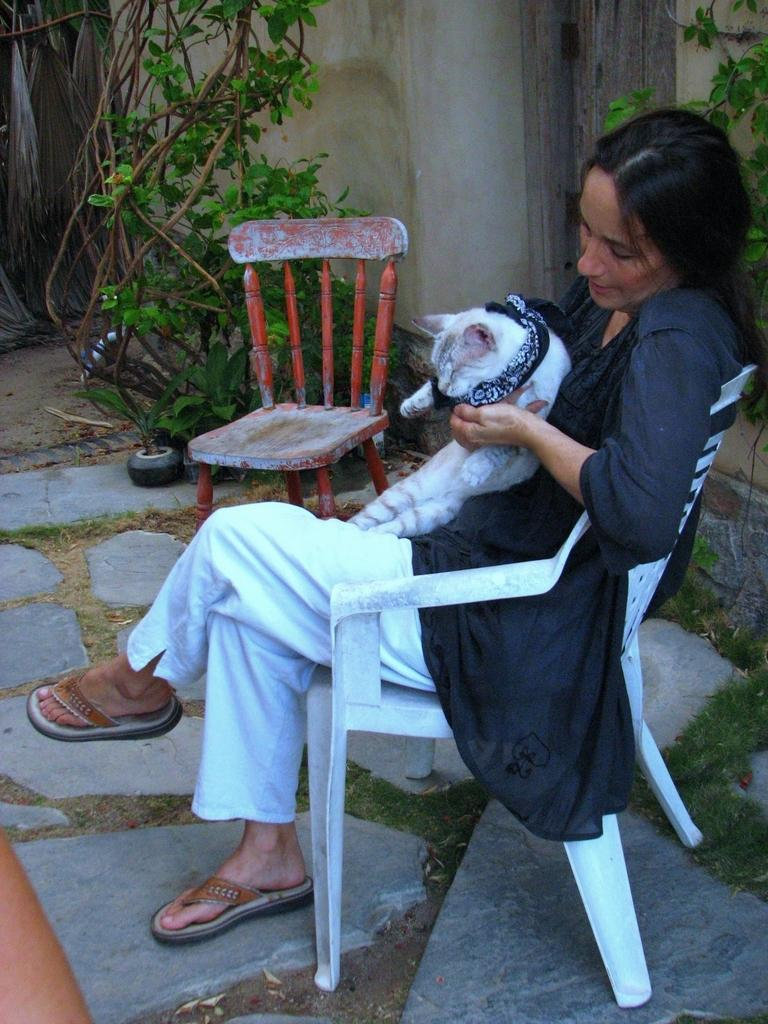Who is present in the image? There is a woman in the image. What is the woman doing in the image? The woman is sitting in a chair. What is the woman holding in her hand? The woman is holding a cat in her hand. Are there any other chairs visible in the image? Yes, there is another chair beside the woman. What can be seen in the background of the image? There is a plant in the background of the image. What type of donkey can be seen grazing in the bushes behind the woman in the image? There is no donkey or bushes present in the image. 